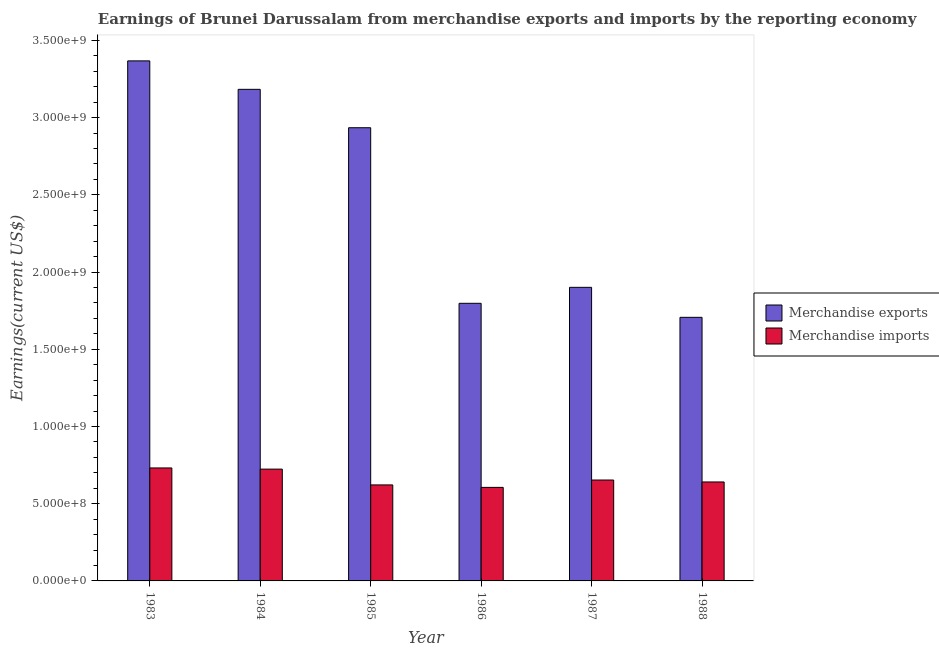Are the number of bars per tick equal to the number of legend labels?
Give a very brief answer. Yes. Are the number of bars on each tick of the X-axis equal?
Make the answer very short. Yes. How many bars are there on the 3rd tick from the left?
Give a very brief answer. 2. How many bars are there on the 3rd tick from the right?
Provide a succinct answer. 2. What is the label of the 4th group of bars from the left?
Offer a very short reply. 1986. What is the earnings from merchandise exports in 1987?
Provide a succinct answer. 1.90e+09. Across all years, what is the maximum earnings from merchandise imports?
Provide a succinct answer. 7.32e+08. Across all years, what is the minimum earnings from merchandise exports?
Your answer should be very brief. 1.71e+09. In which year was the earnings from merchandise exports maximum?
Ensure brevity in your answer.  1983. What is the total earnings from merchandise exports in the graph?
Make the answer very short. 1.49e+1. What is the difference between the earnings from merchandise exports in 1985 and that in 1988?
Provide a short and direct response. 1.23e+09. What is the difference between the earnings from merchandise imports in 1988 and the earnings from merchandise exports in 1983?
Your answer should be very brief. -9.08e+07. What is the average earnings from merchandise imports per year?
Offer a terse response. 6.63e+08. In the year 1983, what is the difference between the earnings from merchandise exports and earnings from merchandise imports?
Your answer should be compact. 0. What is the ratio of the earnings from merchandise exports in 1983 to that in 1984?
Your answer should be very brief. 1.06. Is the earnings from merchandise imports in 1983 less than that in 1987?
Make the answer very short. No. What is the difference between the highest and the second highest earnings from merchandise exports?
Your response must be concise. 1.84e+08. What is the difference between the highest and the lowest earnings from merchandise exports?
Give a very brief answer. 1.66e+09. How many bars are there?
Your answer should be compact. 12. Are all the bars in the graph horizontal?
Give a very brief answer. No. What is the difference between two consecutive major ticks on the Y-axis?
Ensure brevity in your answer.  5.00e+08. How many legend labels are there?
Make the answer very short. 2. What is the title of the graph?
Give a very brief answer. Earnings of Brunei Darussalam from merchandise exports and imports by the reporting economy. What is the label or title of the Y-axis?
Your answer should be compact. Earnings(current US$). What is the Earnings(current US$) in Merchandise exports in 1983?
Provide a succinct answer. 3.37e+09. What is the Earnings(current US$) of Merchandise imports in 1983?
Your response must be concise. 7.32e+08. What is the Earnings(current US$) of Merchandise exports in 1984?
Provide a short and direct response. 3.18e+09. What is the Earnings(current US$) of Merchandise imports in 1984?
Your answer should be compact. 7.24e+08. What is the Earnings(current US$) in Merchandise exports in 1985?
Your response must be concise. 2.93e+09. What is the Earnings(current US$) of Merchandise imports in 1985?
Provide a short and direct response. 6.22e+08. What is the Earnings(current US$) of Merchandise exports in 1986?
Offer a terse response. 1.80e+09. What is the Earnings(current US$) of Merchandise imports in 1986?
Your answer should be compact. 6.06e+08. What is the Earnings(current US$) of Merchandise exports in 1987?
Ensure brevity in your answer.  1.90e+09. What is the Earnings(current US$) in Merchandise imports in 1987?
Your answer should be compact. 6.53e+08. What is the Earnings(current US$) of Merchandise exports in 1988?
Ensure brevity in your answer.  1.71e+09. What is the Earnings(current US$) of Merchandise imports in 1988?
Provide a short and direct response. 6.41e+08. Across all years, what is the maximum Earnings(current US$) in Merchandise exports?
Ensure brevity in your answer.  3.37e+09. Across all years, what is the maximum Earnings(current US$) of Merchandise imports?
Offer a terse response. 7.32e+08. Across all years, what is the minimum Earnings(current US$) in Merchandise exports?
Ensure brevity in your answer.  1.71e+09. Across all years, what is the minimum Earnings(current US$) of Merchandise imports?
Offer a terse response. 6.06e+08. What is the total Earnings(current US$) in Merchandise exports in the graph?
Offer a terse response. 1.49e+1. What is the total Earnings(current US$) in Merchandise imports in the graph?
Your answer should be compact. 3.98e+09. What is the difference between the Earnings(current US$) in Merchandise exports in 1983 and that in 1984?
Keep it short and to the point. 1.84e+08. What is the difference between the Earnings(current US$) of Merchandise imports in 1983 and that in 1984?
Your answer should be very brief. 7.54e+06. What is the difference between the Earnings(current US$) in Merchandise exports in 1983 and that in 1985?
Provide a short and direct response. 4.33e+08. What is the difference between the Earnings(current US$) of Merchandise imports in 1983 and that in 1985?
Your response must be concise. 1.10e+08. What is the difference between the Earnings(current US$) of Merchandise exports in 1983 and that in 1986?
Ensure brevity in your answer.  1.57e+09. What is the difference between the Earnings(current US$) in Merchandise imports in 1983 and that in 1986?
Offer a very short reply. 1.26e+08. What is the difference between the Earnings(current US$) of Merchandise exports in 1983 and that in 1987?
Make the answer very short. 1.47e+09. What is the difference between the Earnings(current US$) of Merchandise imports in 1983 and that in 1987?
Keep it short and to the point. 7.82e+07. What is the difference between the Earnings(current US$) in Merchandise exports in 1983 and that in 1988?
Ensure brevity in your answer.  1.66e+09. What is the difference between the Earnings(current US$) in Merchandise imports in 1983 and that in 1988?
Keep it short and to the point. 9.08e+07. What is the difference between the Earnings(current US$) in Merchandise exports in 1984 and that in 1985?
Your response must be concise. 2.49e+08. What is the difference between the Earnings(current US$) in Merchandise imports in 1984 and that in 1985?
Make the answer very short. 1.02e+08. What is the difference between the Earnings(current US$) of Merchandise exports in 1984 and that in 1986?
Give a very brief answer. 1.39e+09. What is the difference between the Earnings(current US$) in Merchandise imports in 1984 and that in 1986?
Provide a succinct answer. 1.18e+08. What is the difference between the Earnings(current US$) of Merchandise exports in 1984 and that in 1987?
Your answer should be very brief. 1.28e+09. What is the difference between the Earnings(current US$) in Merchandise imports in 1984 and that in 1987?
Keep it short and to the point. 7.07e+07. What is the difference between the Earnings(current US$) of Merchandise exports in 1984 and that in 1988?
Your answer should be very brief. 1.48e+09. What is the difference between the Earnings(current US$) in Merchandise imports in 1984 and that in 1988?
Your answer should be very brief. 8.32e+07. What is the difference between the Earnings(current US$) of Merchandise exports in 1985 and that in 1986?
Offer a terse response. 1.14e+09. What is the difference between the Earnings(current US$) in Merchandise imports in 1985 and that in 1986?
Offer a terse response. 1.60e+07. What is the difference between the Earnings(current US$) of Merchandise exports in 1985 and that in 1987?
Offer a very short reply. 1.03e+09. What is the difference between the Earnings(current US$) of Merchandise imports in 1985 and that in 1987?
Provide a short and direct response. -3.16e+07. What is the difference between the Earnings(current US$) in Merchandise exports in 1985 and that in 1988?
Your answer should be compact. 1.23e+09. What is the difference between the Earnings(current US$) of Merchandise imports in 1985 and that in 1988?
Keep it short and to the point. -1.91e+07. What is the difference between the Earnings(current US$) of Merchandise exports in 1986 and that in 1987?
Offer a terse response. -1.03e+08. What is the difference between the Earnings(current US$) of Merchandise imports in 1986 and that in 1987?
Your response must be concise. -4.76e+07. What is the difference between the Earnings(current US$) in Merchandise exports in 1986 and that in 1988?
Your response must be concise. 9.08e+07. What is the difference between the Earnings(current US$) of Merchandise imports in 1986 and that in 1988?
Provide a succinct answer. -3.51e+07. What is the difference between the Earnings(current US$) of Merchandise exports in 1987 and that in 1988?
Make the answer very short. 1.94e+08. What is the difference between the Earnings(current US$) of Merchandise imports in 1987 and that in 1988?
Your answer should be very brief. 1.25e+07. What is the difference between the Earnings(current US$) of Merchandise exports in 1983 and the Earnings(current US$) of Merchandise imports in 1984?
Provide a succinct answer. 2.64e+09. What is the difference between the Earnings(current US$) in Merchandise exports in 1983 and the Earnings(current US$) in Merchandise imports in 1985?
Make the answer very short. 2.75e+09. What is the difference between the Earnings(current US$) in Merchandise exports in 1983 and the Earnings(current US$) in Merchandise imports in 1986?
Make the answer very short. 2.76e+09. What is the difference between the Earnings(current US$) of Merchandise exports in 1983 and the Earnings(current US$) of Merchandise imports in 1987?
Keep it short and to the point. 2.71e+09. What is the difference between the Earnings(current US$) of Merchandise exports in 1983 and the Earnings(current US$) of Merchandise imports in 1988?
Offer a very short reply. 2.73e+09. What is the difference between the Earnings(current US$) of Merchandise exports in 1984 and the Earnings(current US$) of Merchandise imports in 1985?
Offer a very short reply. 2.56e+09. What is the difference between the Earnings(current US$) in Merchandise exports in 1984 and the Earnings(current US$) in Merchandise imports in 1986?
Give a very brief answer. 2.58e+09. What is the difference between the Earnings(current US$) of Merchandise exports in 1984 and the Earnings(current US$) of Merchandise imports in 1987?
Keep it short and to the point. 2.53e+09. What is the difference between the Earnings(current US$) in Merchandise exports in 1984 and the Earnings(current US$) in Merchandise imports in 1988?
Give a very brief answer. 2.54e+09. What is the difference between the Earnings(current US$) in Merchandise exports in 1985 and the Earnings(current US$) in Merchandise imports in 1986?
Make the answer very short. 2.33e+09. What is the difference between the Earnings(current US$) of Merchandise exports in 1985 and the Earnings(current US$) of Merchandise imports in 1987?
Your response must be concise. 2.28e+09. What is the difference between the Earnings(current US$) in Merchandise exports in 1985 and the Earnings(current US$) in Merchandise imports in 1988?
Give a very brief answer. 2.29e+09. What is the difference between the Earnings(current US$) in Merchandise exports in 1986 and the Earnings(current US$) in Merchandise imports in 1987?
Provide a succinct answer. 1.14e+09. What is the difference between the Earnings(current US$) of Merchandise exports in 1986 and the Earnings(current US$) of Merchandise imports in 1988?
Provide a short and direct response. 1.16e+09. What is the difference between the Earnings(current US$) in Merchandise exports in 1987 and the Earnings(current US$) in Merchandise imports in 1988?
Provide a succinct answer. 1.26e+09. What is the average Earnings(current US$) in Merchandise exports per year?
Provide a succinct answer. 2.48e+09. What is the average Earnings(current US$) in Merchandise imports per year?
Your response must be concise. 6.63e+08. In the year 1983, what is the difference between the Earnings(current US$) of Merchandise exports and Earnings(current US$) of Merchandise imports?
Offer a very short reply. 2.64e+09. In the year 1984, what is the difference between the Earnings(current US$) in Merchandise exports and Earnings(current US$) in Merchandise imports?
Your response must be concise. 2.46e+09. In the year 1985, what is the difference between the Earnings(current US$) in Merchandise exports and Earnings(current US$) in Merchandise imports?
Provide a short and direct response. 2.31e+09. In the year 1986, what is the difference between the Earnings(current US$) of Merchandise exports and Earnings(current US$) of Merchandise imports?
Ensure brevity in your answer.  1.19e+09. In the year 1987, what is the difference between the Earnings(current US$) of Merchandise exports and Earnings(current US$) of Merchandise imports?
Your response must be concise. 1.25e+09. In the year 1988, what is the difference between the Earnings(current US$) in Merchandise exports and Earnings(current US$) in Merchandise imports?
Ensure brevity in your answer.  1.07e+09. What is the ratio of the Earnings(current US$) in Merchandise exports in 1983 to that in 1984?
Provide a short and direct response. 1.06. What is the ratio of the Earnings(current US$) of Merchandise imports in 1983 to that in 1984?
Ensure brevity in your answer.  1.01. What is the ratio of the Earnings(current US$) of Merchandise exports in 1983 to that in 1985?
Offer a terse response. 1.15. What is the ratio of the Earnings(current US$) in Merchandise imports in 1983 to that in 1985?
Ensure brevity in your answer.  1.18. What is the ratio of the Earnings(current US$) of Merchandise exports in 1983 to that in 1986?
Offer a terse response. 1.87. What is the ratio of the Earnings(current US$) of Merchandise imports in 1983 to that in 1986?
Offer a very short reply. 1.21. What is the ratio of the Earnings(current US$) in Merchandise exports in 1983 to that in 1987?
Keep it short and to the point. 1.77. What is the ratio of the Earnings(current US$) in Merchandise imports in 1983 to that in 1987?
Make the answer very short. 1.12. What is the ratio of the Earnings(current US$) in Merchandise exports in 1983 to that in 1988?
Offer a terse response. 1.97. What is the ratio of the Earnings(current US$) of Merchandise imports in 1983 to that in 1988?
Offer a very short reply. 1.14. What is the ratio of the Earnings(current US$) in Merchandise exports in 1984 to that in 1985?
Provide a succinct answer. 1.08. What is the ratio of the Earnings(current US$) in Merchandise imports in 1984 to that in 1985?
Your answer should be very brief. 1.16. What is the ratio of the Earnings(current US$) of Merchandise exports in 1984 to that in 1986?
Ensure brevity in your answer.  1.77. What is the ratio of the Earnings(current US$) in Merchandise imports in 1984 to that in 1986?
Keep it short and to the point. 1.2. What is the ratio of the Earnings(current US$) in Merchandise exports in 1984 to that in 1987?
Keep it short and to the point. 1.67. What is the ratio of the Earnings(current US$) of Merchandise imports in 1984 to that in 1987?
Make the answer very short. 1.11. What is the ratio of the Earnings(current US$) in Merchandise exports in 1984 to that in 1988?
Make the answer very short. 1.86. What is the ratio of the Earnings(current US$) of Merchandise imports in 1984 to that in 1988?
Provide a succinct answer. 1.13. What is the ratio of the Earnings(current US$) in Merchandise exports in 1985 to that in 1986?
Give a very brief answer. 1.63. What is the ratio of the Earnings(current US$) of Merchandise imports in 1985 to that in 1986?
Provide a succinct answer. 1.03. What is the ratio of the Earnings(current US$) of Merchandise exports in 1985 to that in 1987?
Your response must be concise. 1.54. What is the ratio of the Earnings(current US$) in Merchandise imports in 1985 to that in 1987?
Ensure brevity in your answer.  0.95. What is the ratio of the Earnings(current US$) of Merchandise exports in 1985 to that in 1988?
Offer a very short reply. 1.72. What is the ratio of the Earnings(current US$) of Merchandise imports in 1985 to that in 1988?
Keep it short and to the point. 0.97. What is the ratio of the Earnings(current US$) of Merchandise exports in 1986 to that in 1987?
Provide a succinct answer. 0.95. What is the ratio of the Earnings(current US$) of Merchandise imports in 1986 to that in 1987?
Ensure brevity in your answer.  0.93. What is the ratio of the Earnings(current US$) of Merchandise exports in 1986 to that in 1988?
Keep it short and to the point. 1.05. What is the ratio of the Earnings(current US$) of Merchandise imports in 1986 to that in 1988?
Make the answer very short. 0.95. What is the ratio of the Earnings(current US$) in Merchandise exports in 1987 to that in 1988?
Provide a short and direct response. 1.11. What is the ratio of the Earnings(current US$) in Merchandise imports in 1987 to that in 1988?
Your answer should be compact. 1.02. What is the difference between the highest and the second highest Earnings(current US$) of Merchandise exports?
Give a very brief answer. 1.84e+08. What is the difference between the highest and the second highest Earnings(current US$) of Merchandise imports?
Make the answer very short. 7.54e+06. What is the difference between the highest and the lowest Earnings(current US$) of Merchandise exports?
Your answer should be compact. 1.66e+09. What is the difference between the highest and the lowest Earnings(current US$) in Merchandise imports?
Make the answer very short. 1.26e+08. 